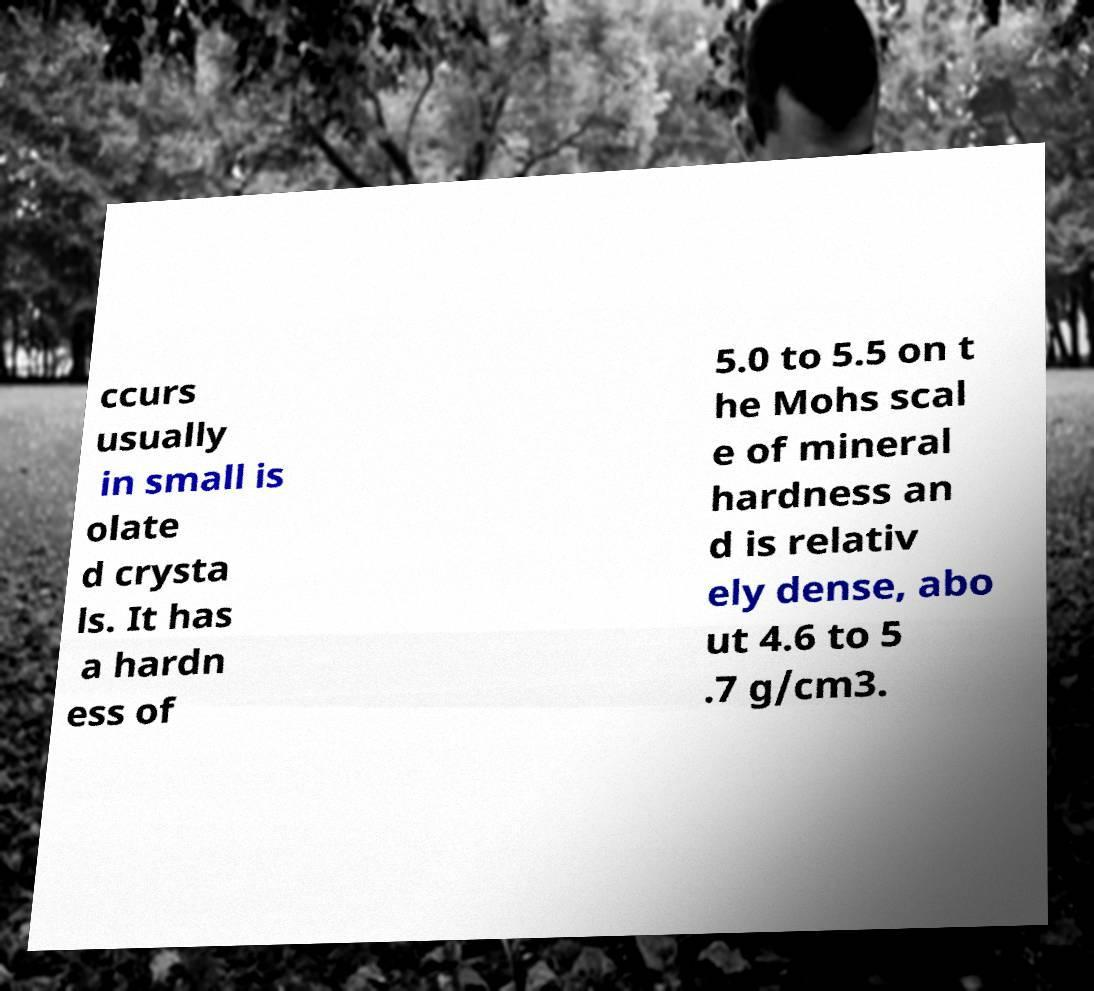Can you accurately transcribe the text from the provided image for me? ccurs usually in small is olate d crysta ls. It has a hardn ess of 5.0 to 5.5 on t he Mohs scal e of mineral hardness an d is relativ ely dense, abo ut 4.6 to 5 .7 g/cm3. 